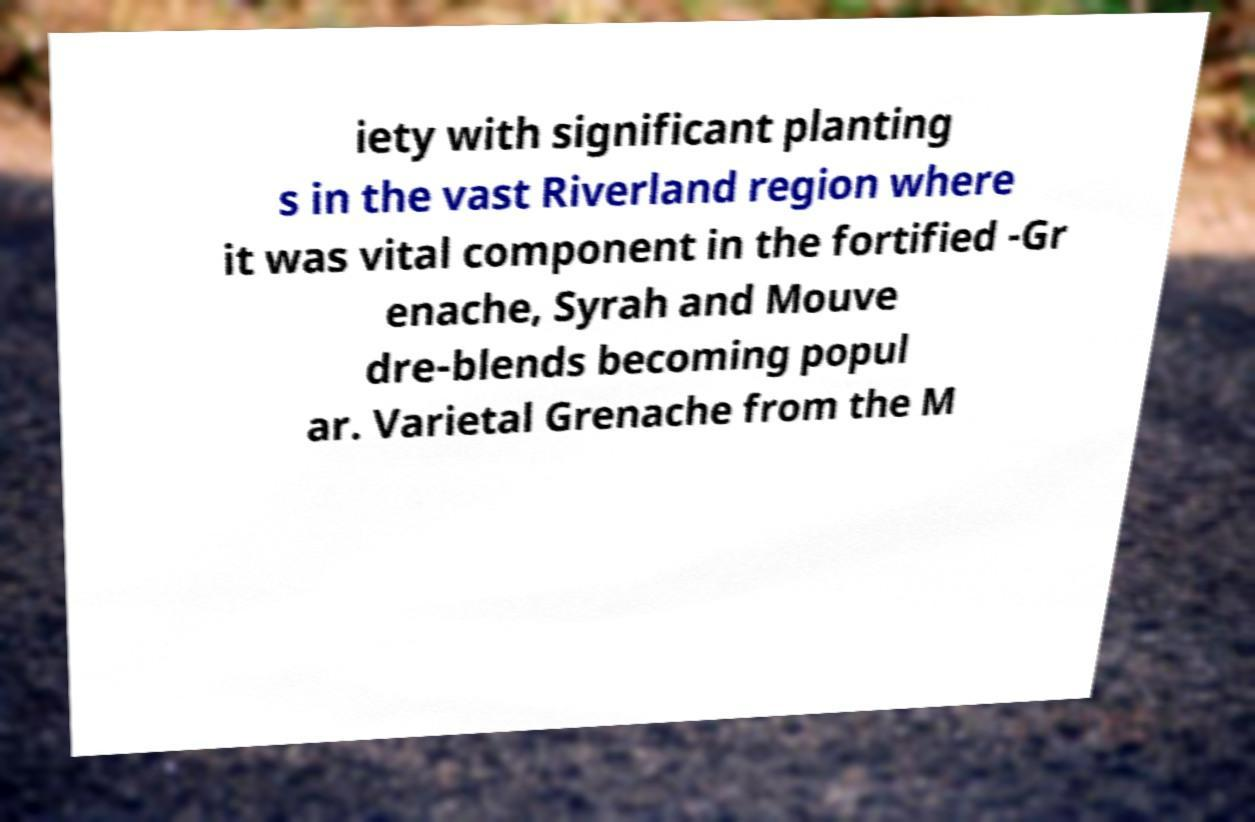What messages or text are displayed in this image? I need them in a readable, typed format. iety with significant planting s in the vast Riverland region where it was vital component in the fortified -Gr enache, Syrah and Mouve dre-blends becoming popul ar. Varietal Grenache from the M 